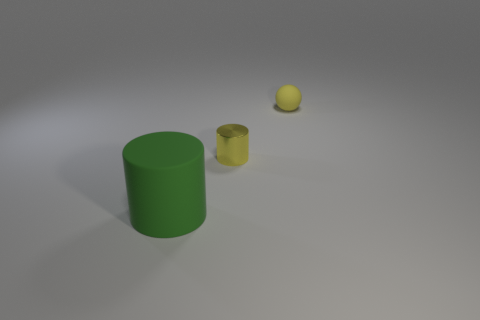Is there anything else that has the same size as the rubber cylinder?
Offer a terse response. No. Is there a tiny shiny object left of the yellow matte object to the right of the metallic thing?
Your response must be concise. Yes. There is a yellow cylinder; are there any tiny matte spheres right of it?
Give a very brief answer. Yes. There is a yellow object on the left side of the sphere; does it have the same shape as the large green rubber object?
Your answer should be compact. Yes. How many big purple rubber things are the same shape as the green matte object?
Ensure brevity in your answer.  0. Are there any large green cylinders that have the same material as the sphere?
Offer a very short reply. Yes. What material is the tiny yellow object that is left of the matte object right of the metal cylinder?
Offer a terse response. Metal. What size is the yellow thing behind the small yellow cylinder?
Keep it short and to the point. Small. There is a tiny shiny cylinder; is its color the same as the object behind the yellow metallic object?
Your answer should be compact. Yes. Is there a metal cylinder that has the same color as the sphere?
Your answer should be very brief. Yes. 